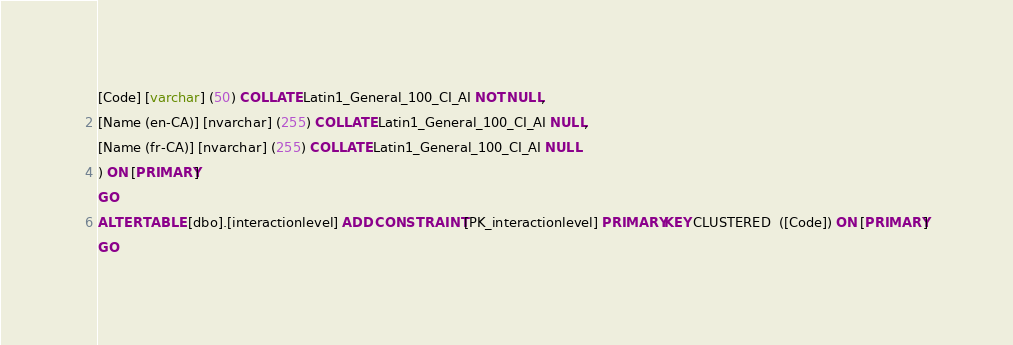Convert code to text. <code><loc_0><loc_0><loc_500><loc_500><_SQL_>[Code] [varchar] (50) COLLATE Latin1_General_100_CI_AI NOT NULL,
[Name (en-CA)] [nvarchar] (255) COLLATE Latin1_General_100_CI_AI NULL,
[Name (fr-CA)] [nvarchar] (255) COLLATE Latin1_General_100_CI_AI NULL
) ON [PRIMARY]
GO
ALTER TABLE [dbo].[interactionlevel] ADD CONSTRAINT [PK_interactionlevel] PRIMARY KEY CLUSTERED  ([Code]) ON [PRIMARY]
GO
</code> 